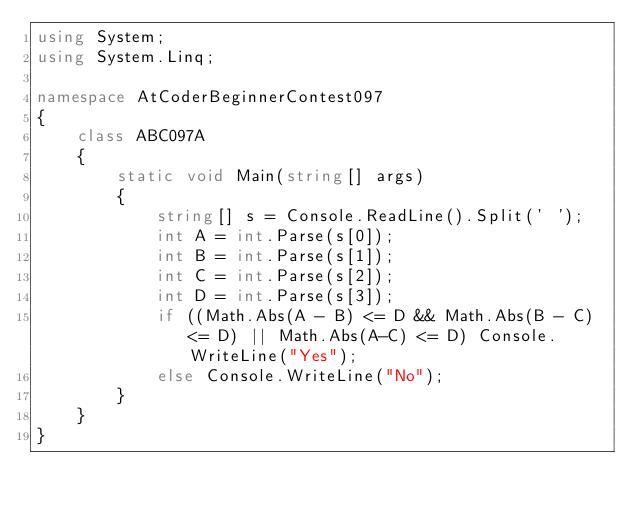Convert code to text. <code><loc_0><loc_0><loc_500><loc_500><_C#_>using System;
using System.Linq;

namespace AtCoderBeginnerContest097
{
    class ABC097A
    {
        static void Main(string[] args)
        {
            string[] s = Console.ReadLine().Split(' ');
            int A = int.Parse(s[0]);
            int B = int.Parse(s[1]);
            int C = int.Parse(s[2]);
            int D = int.Parse(s[3]);
            if ((Math.Abs(A - B) <= D && Math.Abs(B - C) <= D) || Math.Abs(A-C) <= D) Console.WriteLine("Yes");
            else Console.WriteLine("No");
        }
    }
}
</code> 